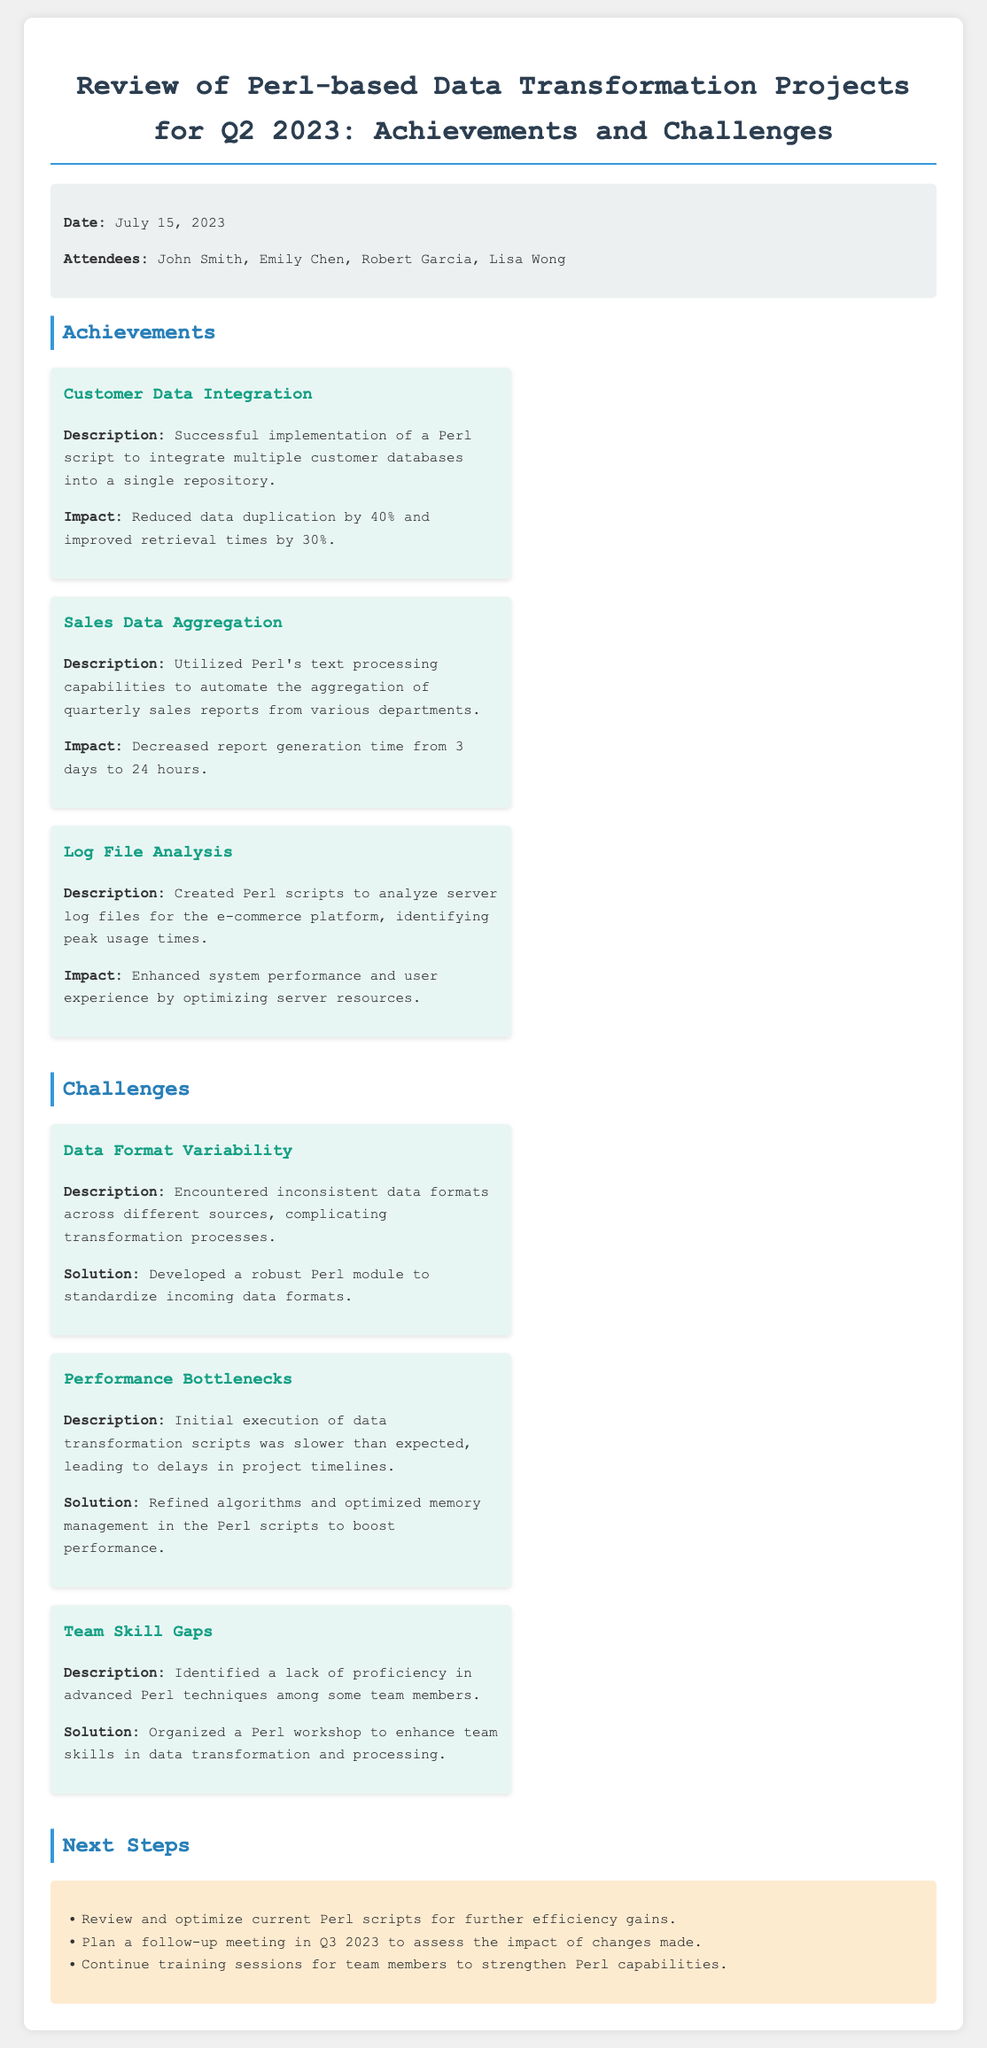what is the date of the review meeting? The date of the review meeting is explicitly mentioned in the document as July 15, 2023.
Answer: July 15, 2023 who is one of the attendees? The document lists attendees, among them is John Smith, whose name is explicitly stated.
Answer: John Smith what percentage did data duplication reduce by in customer data integration? The achievement section states that data duplication was reduced by 40% through successful implementation.
Answer: 40% what was the impact on report generation time for sales data aggregation? The document specifies that report generation time decreased from 3 days to 24 hours, which highlights the efficiency gained.
Answer: 24 hours what was a major challenge faced regarding data formats? The text specifically mentions encountering inconsistent data formats across different sources as a key challenge.
Answer: Inconsistent data formats what was the solution for performance bottlenecks? The document states that the solution involved refining algorithms and optimizing memory management in the Perl scripts to enhance performance.
Answer: Optimized memory management what type of training was organized to address team skill gaps? The document indicates that a Perl workshop was organized to enhance team skills in data transformation and processing.
Answer: Perl workshop how many steps are listed under next steps? The next steps section presents three distinct action items to be undertaken moving forward, explicitly stated in a list.
Answer: Three steps 